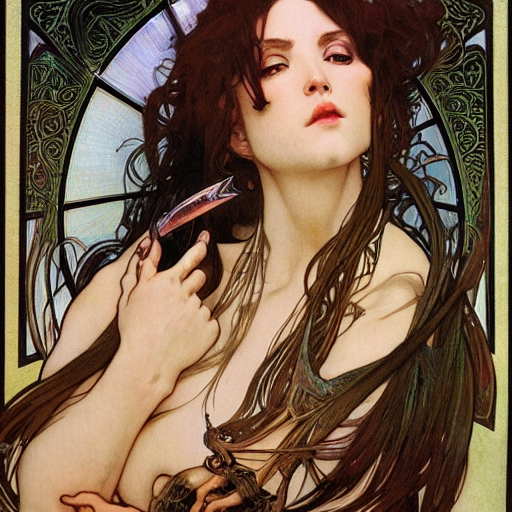Is the lighting sufficient?
A. No
B. Yes
Answer with the option's letter from the given choices directly.
 B. 